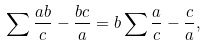<formula> <loc_0><loc_0><loc_500><loc_500>\sum \frac { a b } { c } - \frac { b c } { a } = b \sum \frac { a } { c } - \frac { c } { a } ,</formula> 